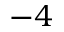<formula> <loc_0><loc_0><loc_500><loc_500>- 4</formula> 